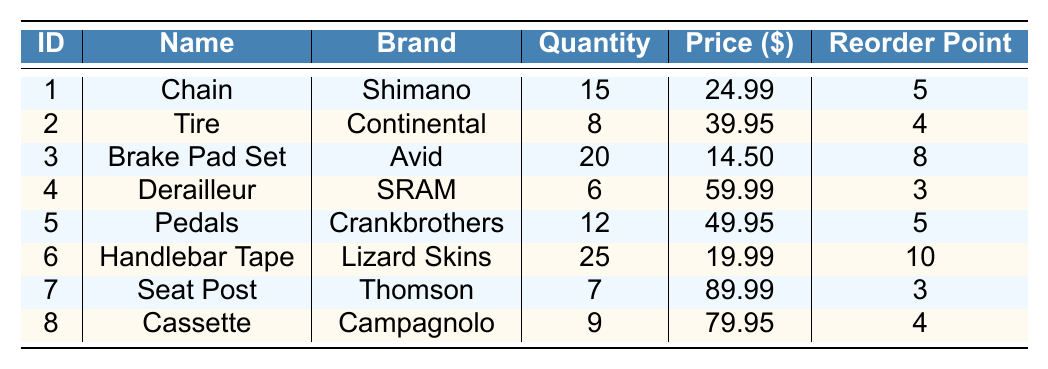What is the quantity of Brake Pad Set? The quantity for Brake Pad Set is listed as 20 in the table under the "Quantity" column.
Answer: 20 How many Derailleurs are in stock? The stock level for Derailleurs is shown as 6 in the "Quantity" column of the table.
Answer: 6 Which part has the highest price? The highest price in the table is for the Seat Post, which is listed at $89.99.
Answer: Seat Post What is the total quantity of all the bicycle parts? To find the total quantity, add all the quantities listed: 15 + 8 + 20 + 6 + 12 + 25 + 7 + 9 = 102.
Answer: 102 Is the reorder point for Handlebar Tape higher than 5? The reorder point for Handlebar Tape is 10, which is indeed higher than 5.
Answer: Yes How many parts have a reorder point of 4 or lower? The parts with a reorder point of 4 or lower are Tire (4), Derailleur (3), and Cassette (4); this totals 3 parts.
Answer: 3 What is the average price of all the parts? The total price can be calculated as 24.99 + 39.95 + 14.50 + 59.99 + 49.95 + 19.99 + 89.99 + 79.95 = 379.31; there are 8 parts, so the average price is 379.31 / 8 = 47.41.
Answer: 47.41 Is there a part with a quantity below its reorder point? Yes, the Derailleur has a quantity of 6, which is below its reorder point of 3.
Answer: Yes Which part has the lowest quantity and what is that quantity? The part with the lowest quantity is the Derailleur, which has a quantity of 6.
Answer: 6 What is the difference in quantity between the part with the highest and lowest stock? The part with the highest stock is Handlebar Tape (25) and the lowest is Derailleur (6). Their difference is 25 - 6 = 19.
Answer: 19 